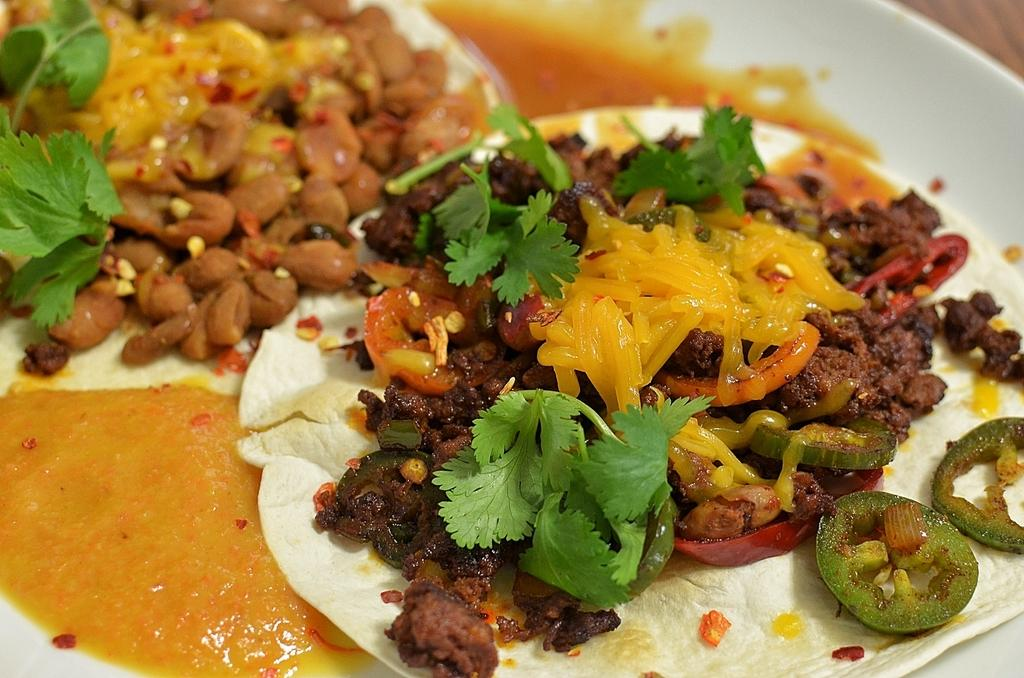What is located in the center of the image? There is a table in the center of the image. What is placed on the table? There is a plate on the table. What can be found on the plate? There are food items on the plate. What type of flower is growing on the plate in the image? There is no flower growing on the plate in the image; it contains food items. 